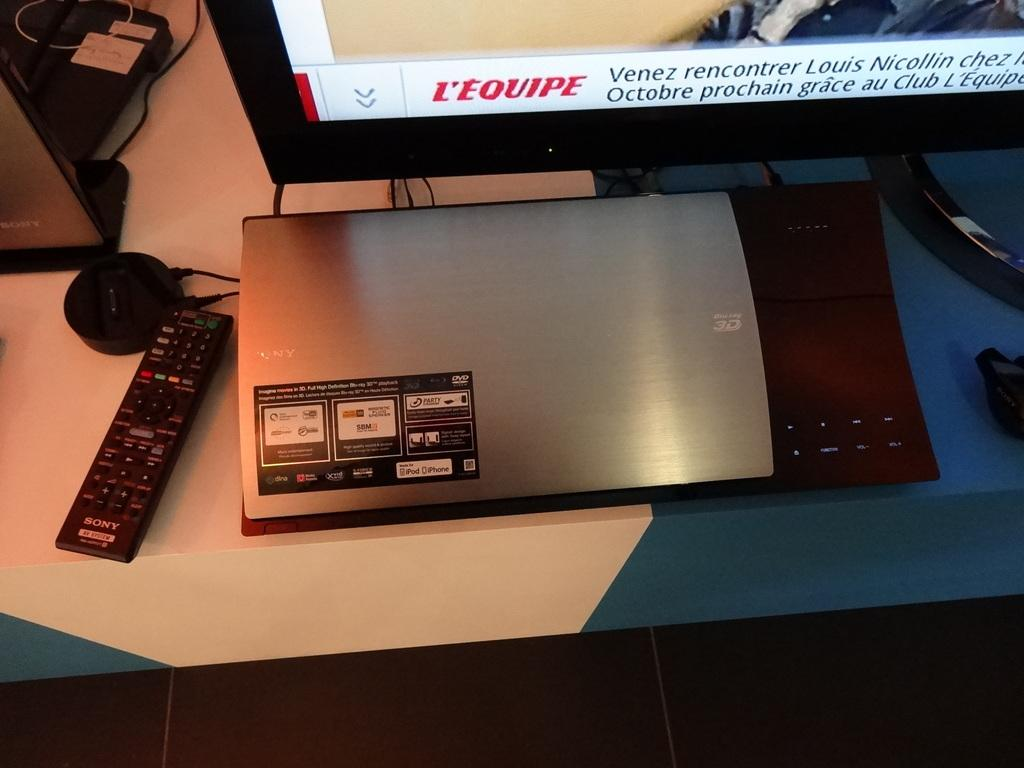<image>
Relay a brief, clear account of the picture shown. An electronic device in front of a tv and next to a  Sony brand remote. 